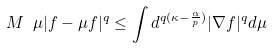Convert formula to latex. <formula><loc_0><loc_0><loc_500><loc_500>M \ \mu | f - \mu f | ^ { q } \leq \int d ^ { q ( \kappa - \frac { \alpha } { p } ) } | \nabla f | ^ { q } d \mu</formula> 